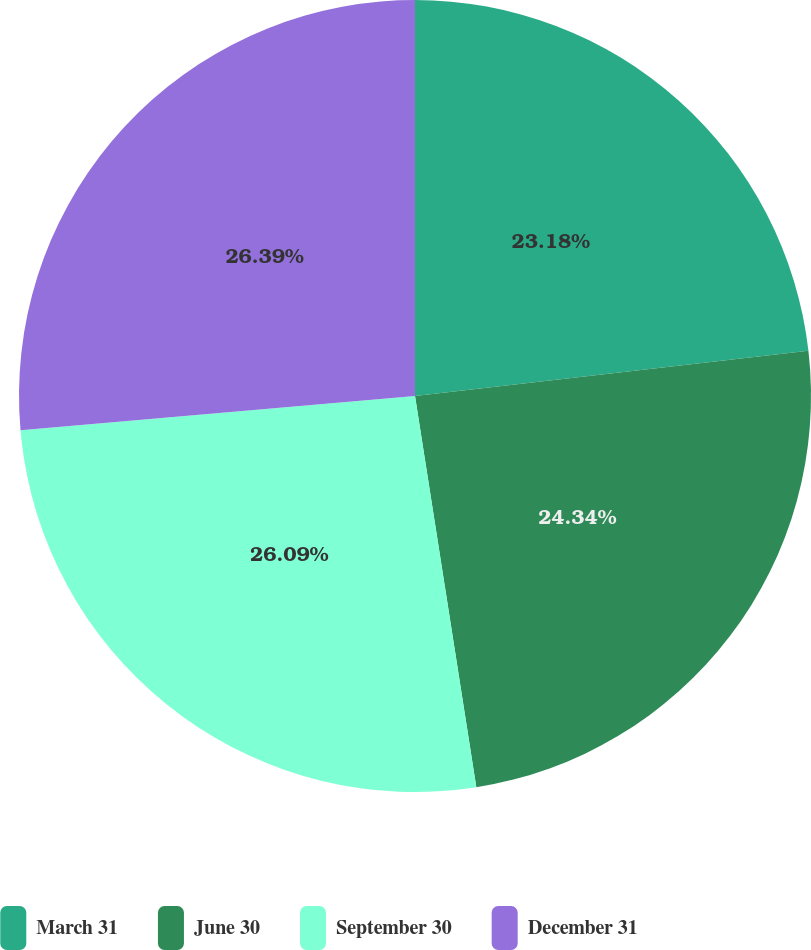<chart> <loc_0><loc_0><loc_500><loc_500><pie_chart><fcel>March 31<fcel>June 30<fcel>September 30<fcel>December 31<nl><fcel>23.18%<fcel>24.34%<fcel>26.09%<fcel>26.38%<nl></chart> 